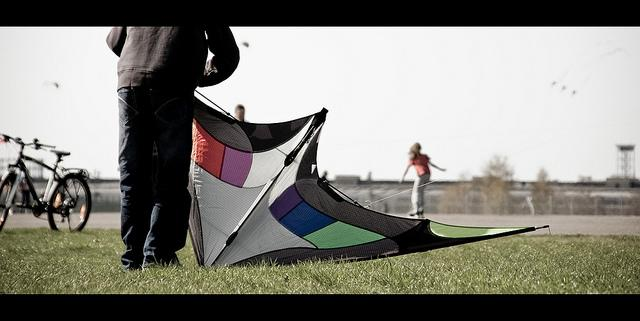How did the kite flyer get to the park? bicycle 